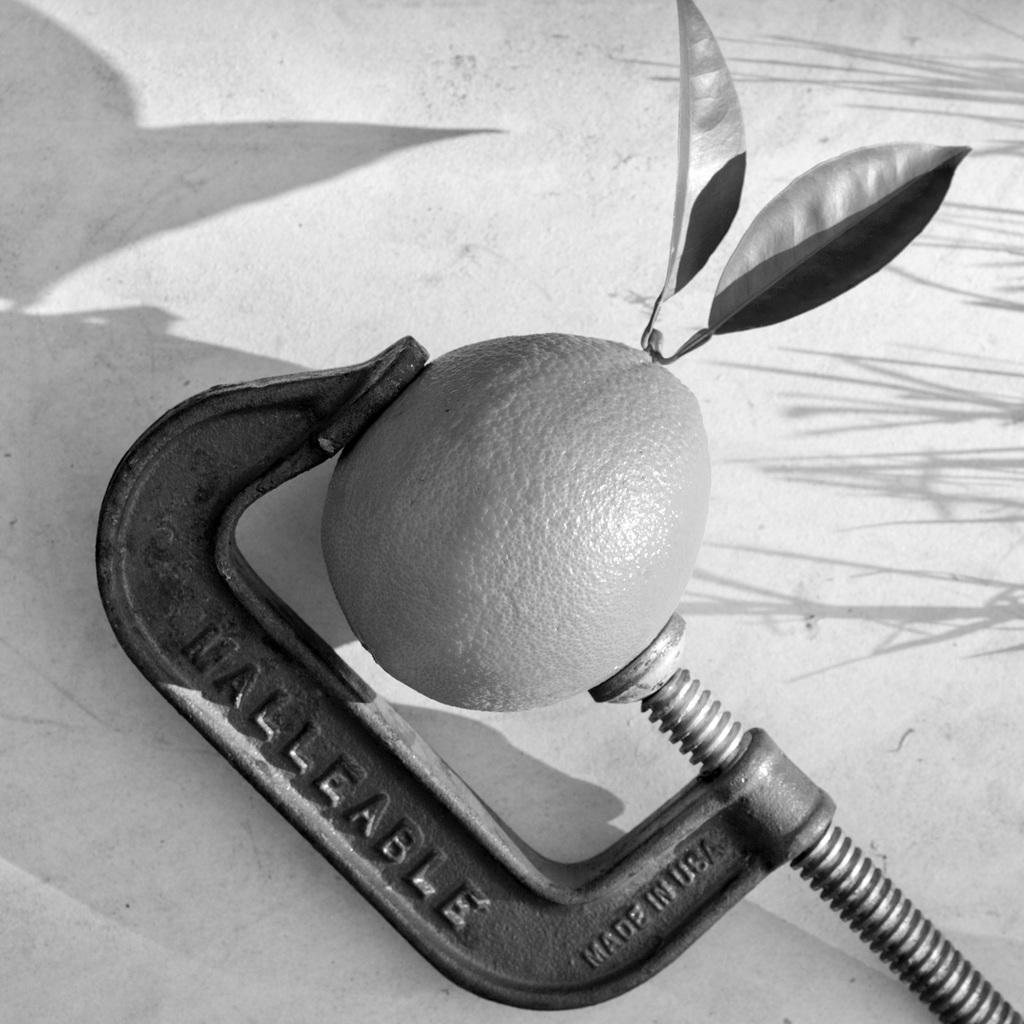Provide a one-sentence caption for the provided image. Malleable that is Made in the USA that is squeezing a orange. 